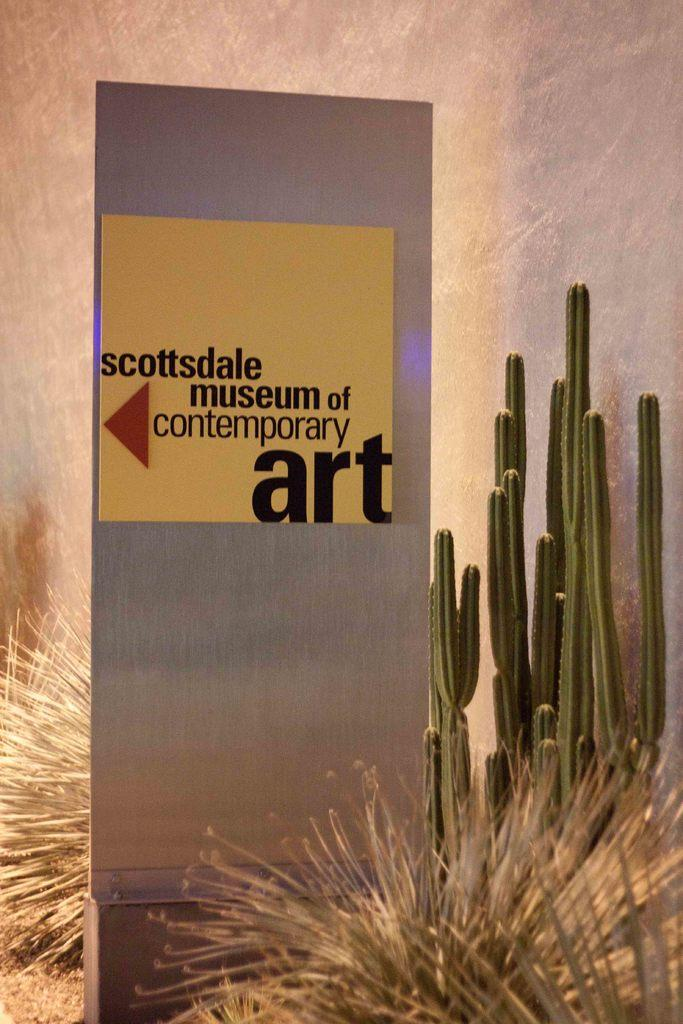What is the color of the object in the image? The object in the image is silver-colored. What is written on the silver-colored object? There is writing on the silver-colored object. What type of plant can be seen in the image? There is a cactus in the image, as well as other plants. What park is featured in the image? There is no park present in the image; it contains a silver-colored object, a cactus, and other plants. What territory is depicted in the image? The image does not depict a specific territory; it shows a silver-colored object, a cactus, and other plants. 